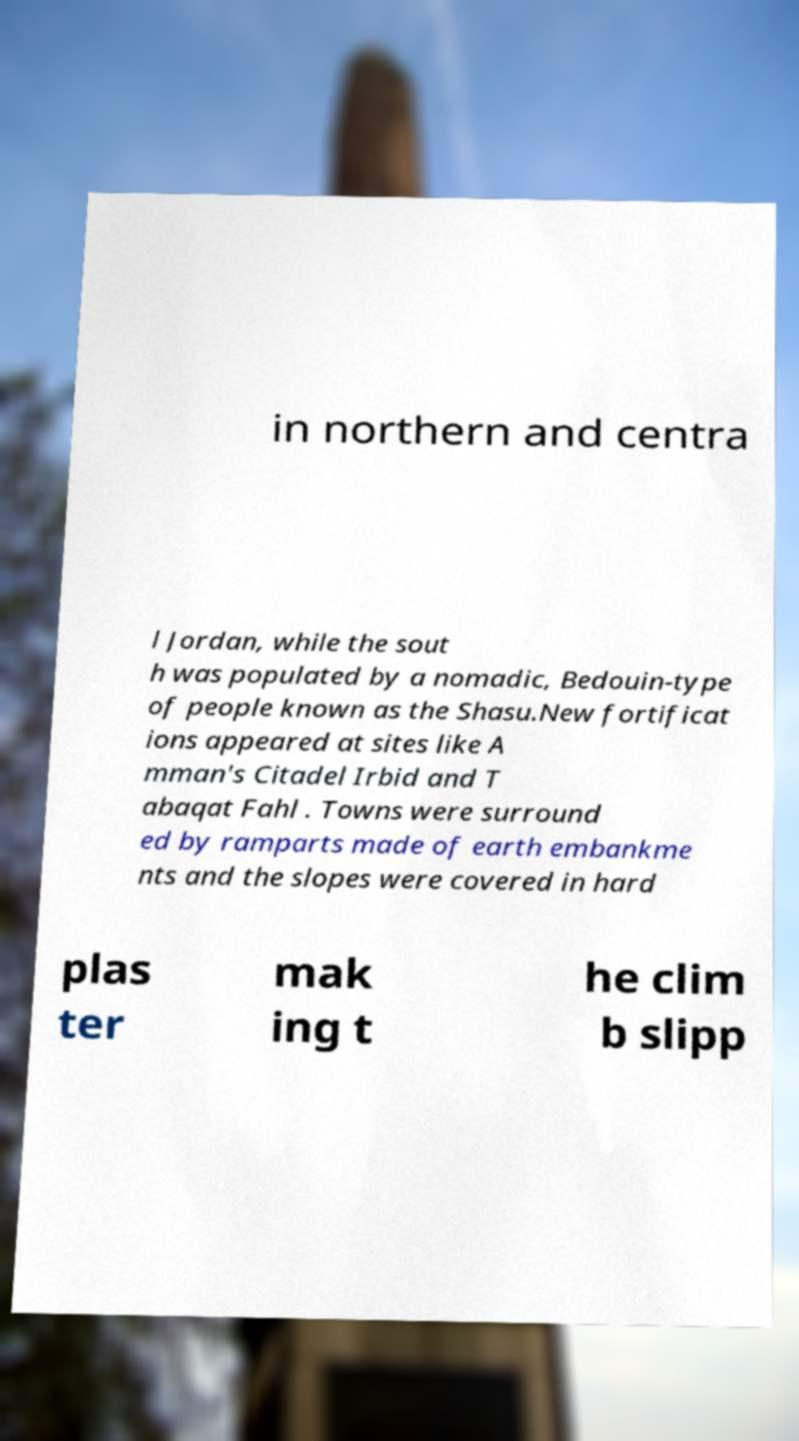Please identify and transcribe the text found in this image. in northern and centra l Jordan, while the sout h was populated by a nomadic, Bedouin-type of people known as the Shasu.New fortificat ions appeared at sites like A mman's Citadel Irbid and T abaqat Fahl . Towns were surround ed by ramparts made of earth embankme nts and the slopes were covered in hard plas ter mak ing t he clim b slipp 